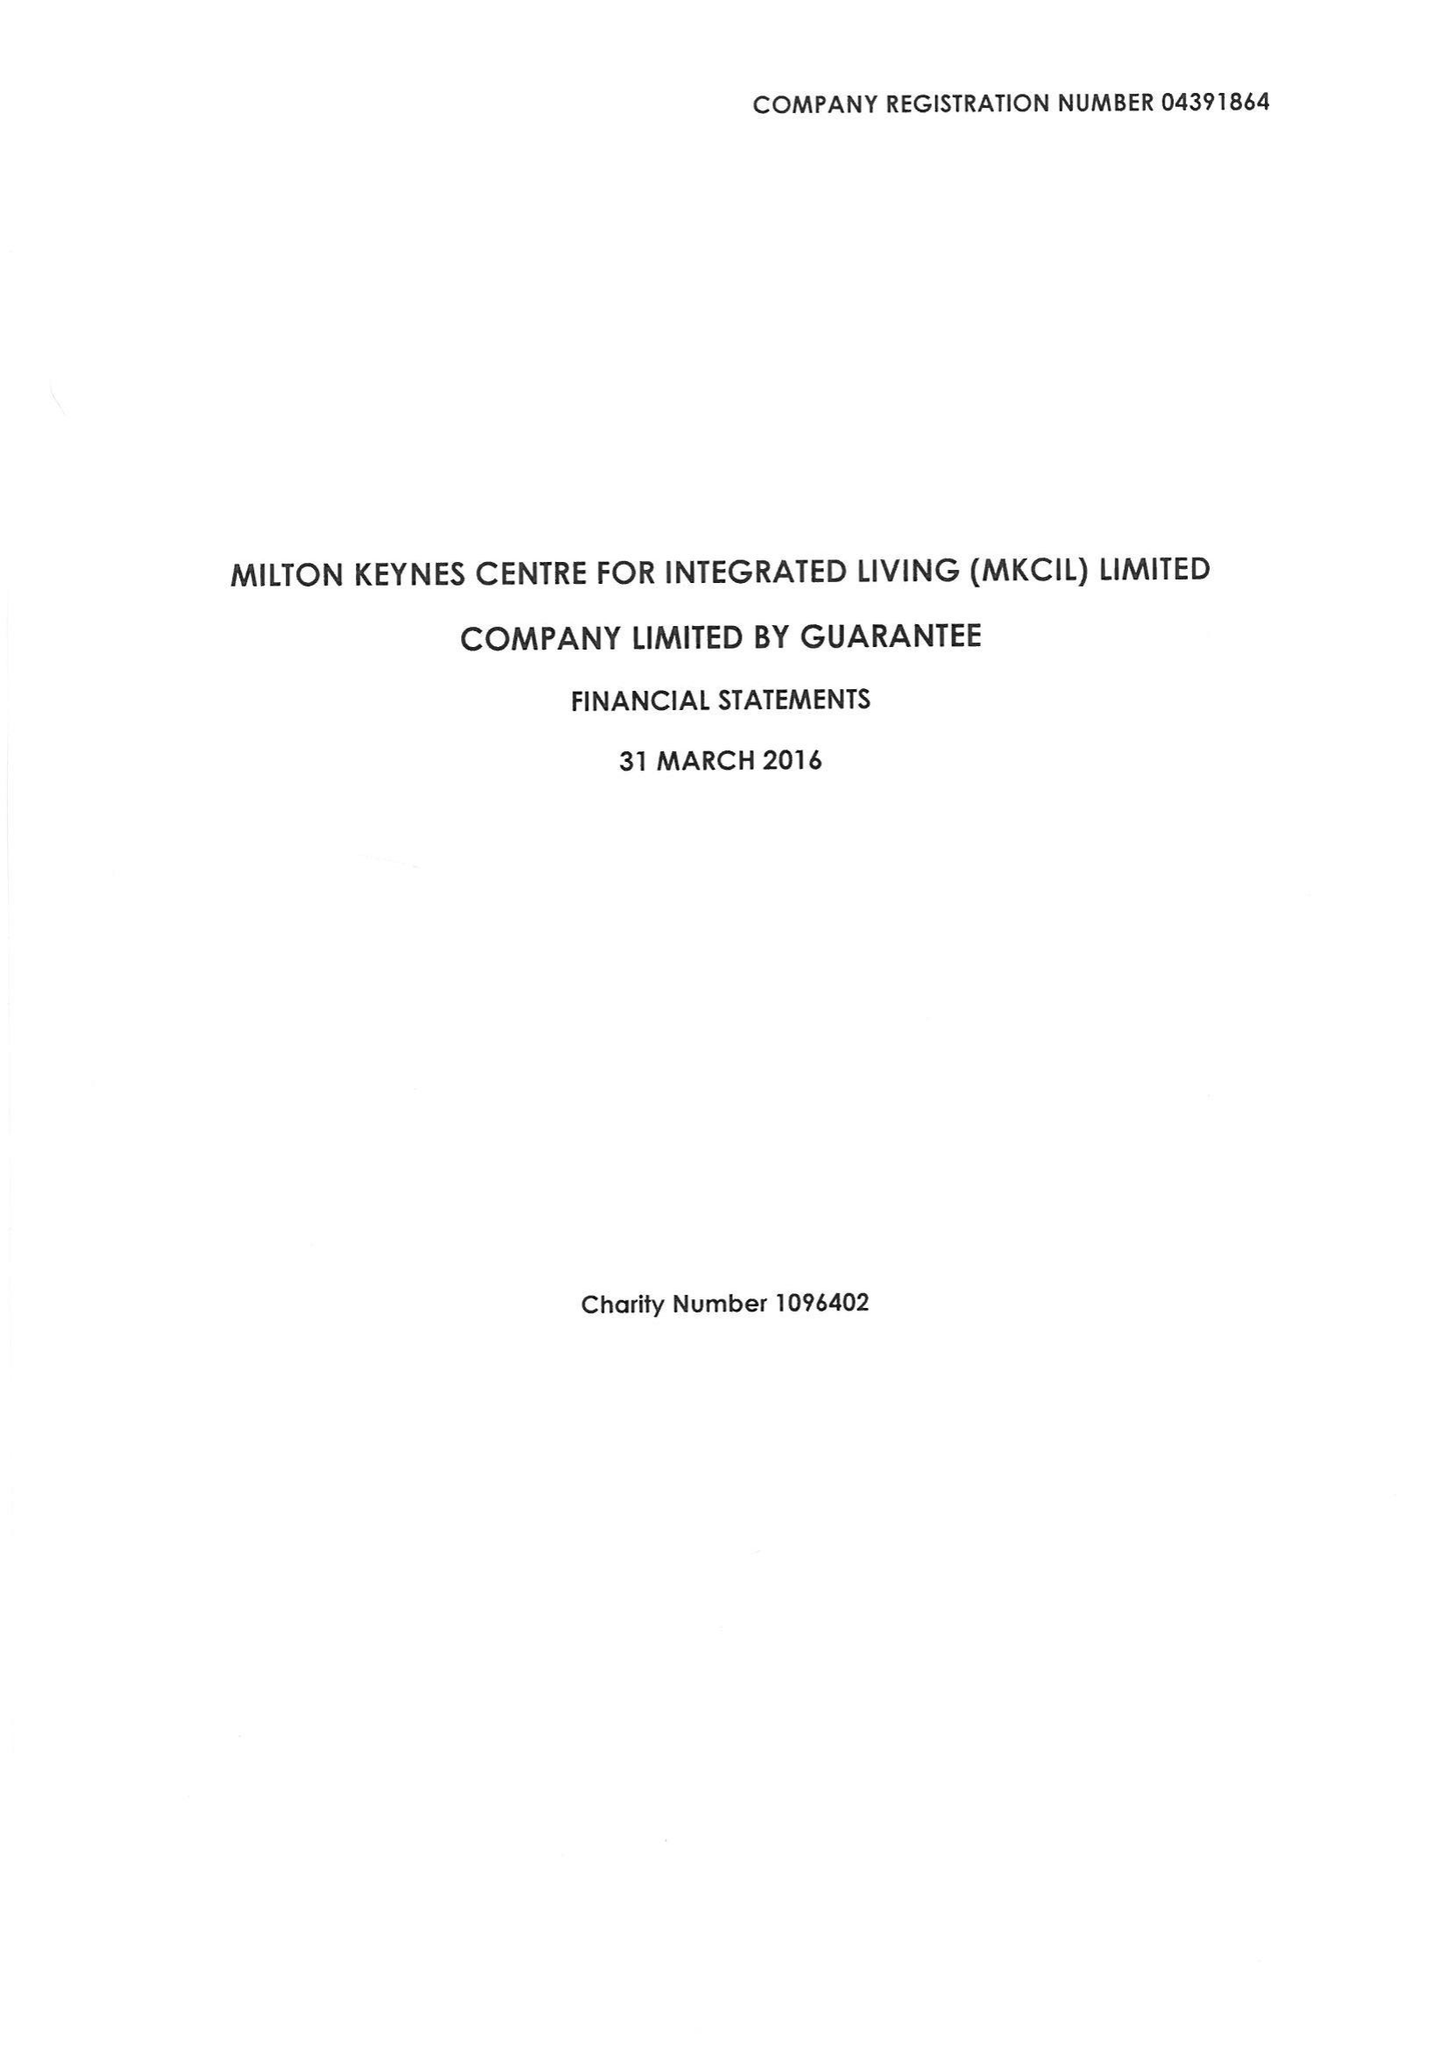What is the value for the charity_number?
Answer the question using a single word or phrase. 1096402 